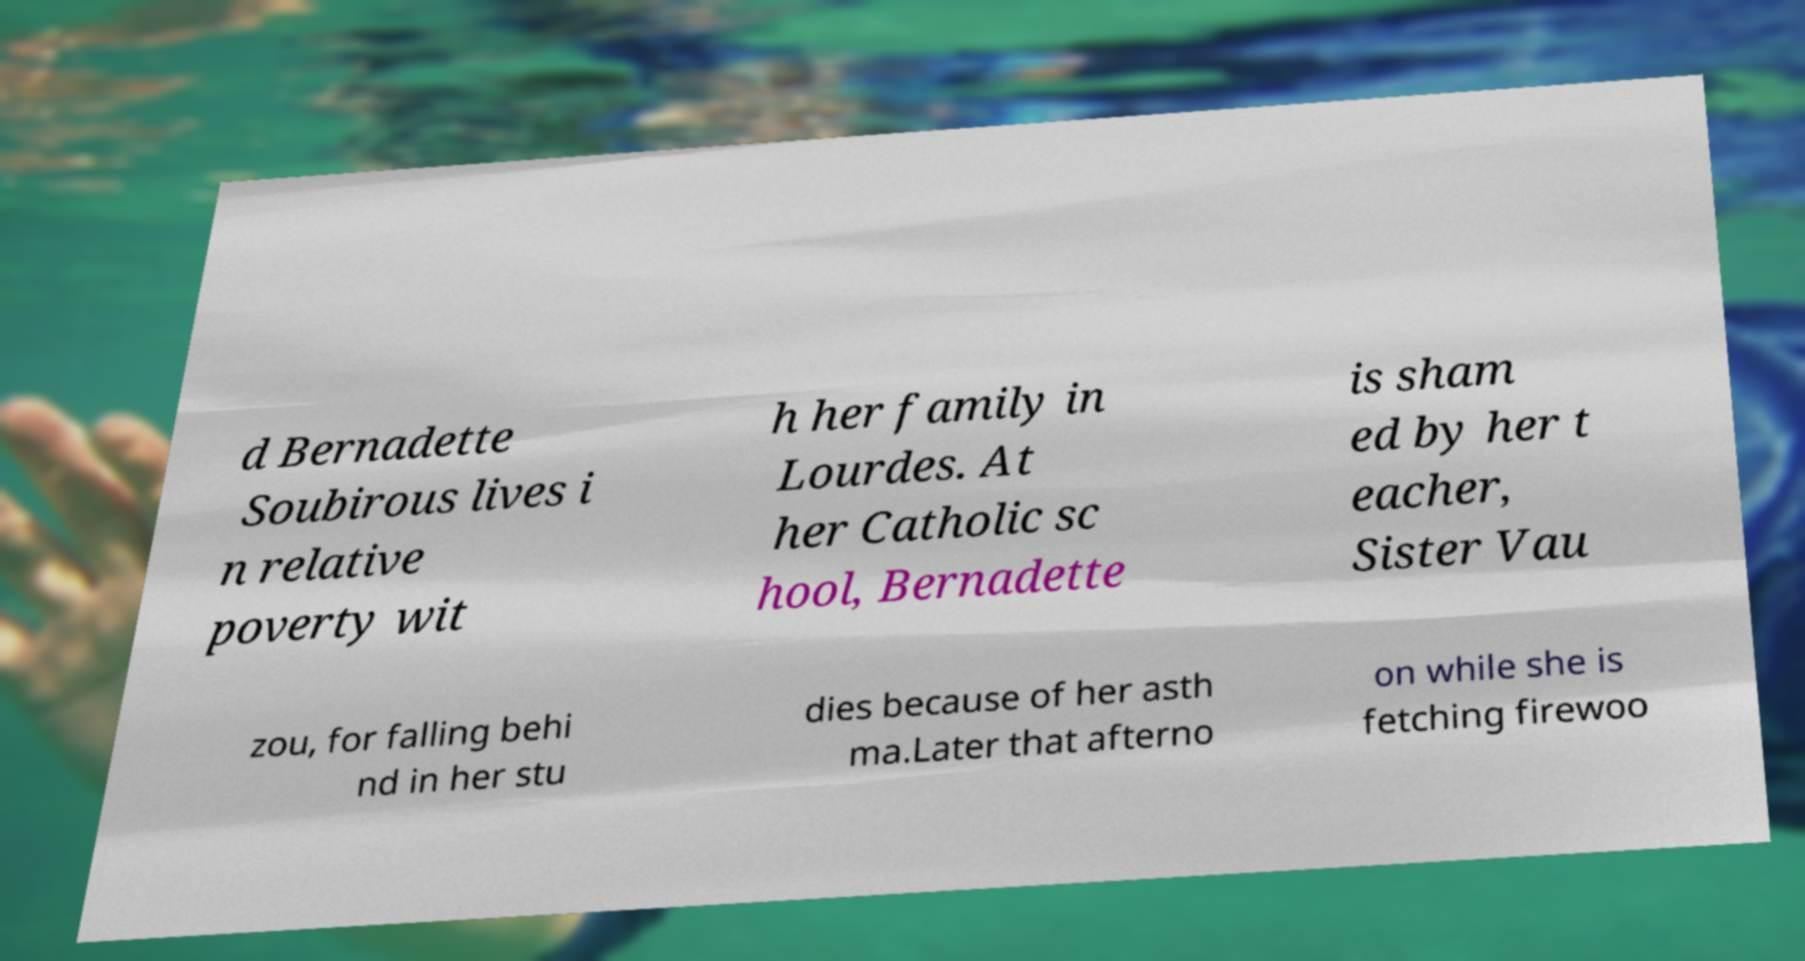Can you read and provide the text displayed in the image?This photo seems to have some interesting text. Can you extract and type it out for me? d Bernadette Soubirous lives i n relative poverty wit h her family in Lourdes. At her Catholic sc hool, Bernadette is sham ed by her t eacher, Sister Vau zou, for falling behi nd in her stu dies because of her asth ma.Later that afterno on while she is fetching firewoo 